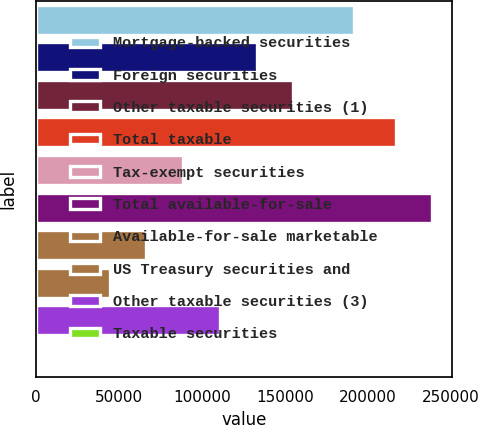<chart> <loc_0><loc_0><loc_500><loc_500><bar_chart><fcel>Mortgage-backed securities<fcel>Foreign securities<fcel>Other taxable securities (1)<fcel>Total taxable<fcel>Tax-exempt securities<fcel>Total available-for-sale<fcel>Available-for-sale marketable<fcel>US Treasury securities and<fcel>Other taxable securities (3)<fcel>Taxable securities<nl><fcel>192031<fcel>132950<fcel>155102<fcel>216864<fcel>88647<fcel>239016<fcel>66495.5<fcel>44344<fcel>110798<fcel>41<nl></chart> 